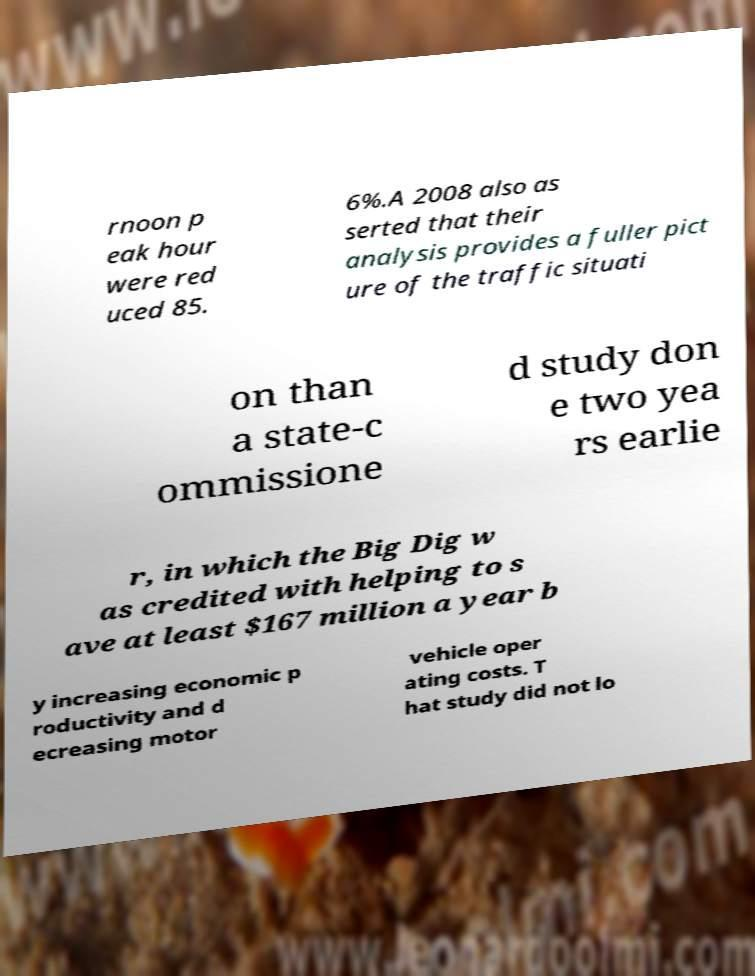Could you extract and type out the text from this image? rnoon p eak hour were red uced 85. 6%.A 2008 also as serted that their analysis provides a fuller pict ure of the traffic situati on than a state-c ommissione d study don e two yea rs earlie r, in which the Big Dig w as credited with helping to s ave at least $167 million a year b y increasing economic p roductivity and d ecreasing motor vehicle oper ating costs. T hat study did not lo 